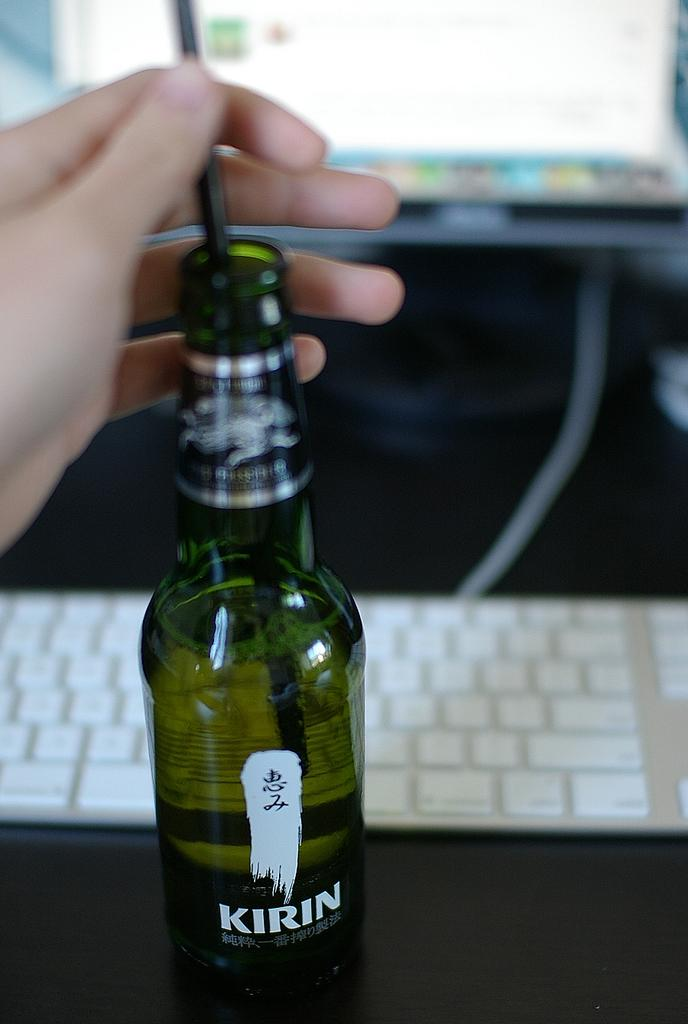What part of a person can be seen in the image? There is a hand of a person in the image. What object is present in the image that might be used for holding or storing liquids? There is a bottle in the image. What can be seen in the image that might be used for inputting data or controlling a device? There is a keyboard in the image. What is the main subject or system visible in the image? There is a system in the image. What type of silk material is draped over the keyboard in the image? There is no silk material present in the image; it only features a hand, a bottle, a system, and a keyboard. 